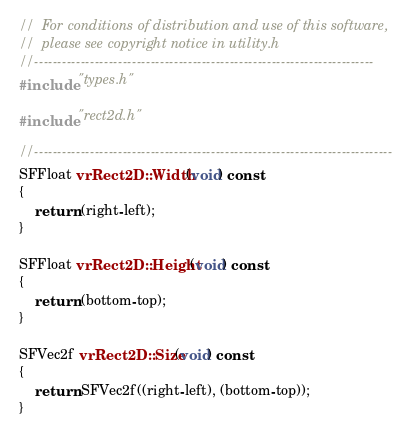<code> <loc_0><loc_0><loc_500><loc_500><_C++_>//  For conditions of distribution and use of this software,
//  please see copyright notice in utility.h
//-------------------------------------------------------------------------
#include "types.h"

#include "rect2d.h"

//-----------------------------------------------------------------------------
SFFloat vrRect2D::Width(void) const
{
	return (right-left);
}

SFFloat vrRect2D::Height(void) const
{
	return (bottom-top);
}

SFVec2f vrRect2D::Size(void) const
{
	return SFVec2f((right-left), (bottom-top));
}

</code> 